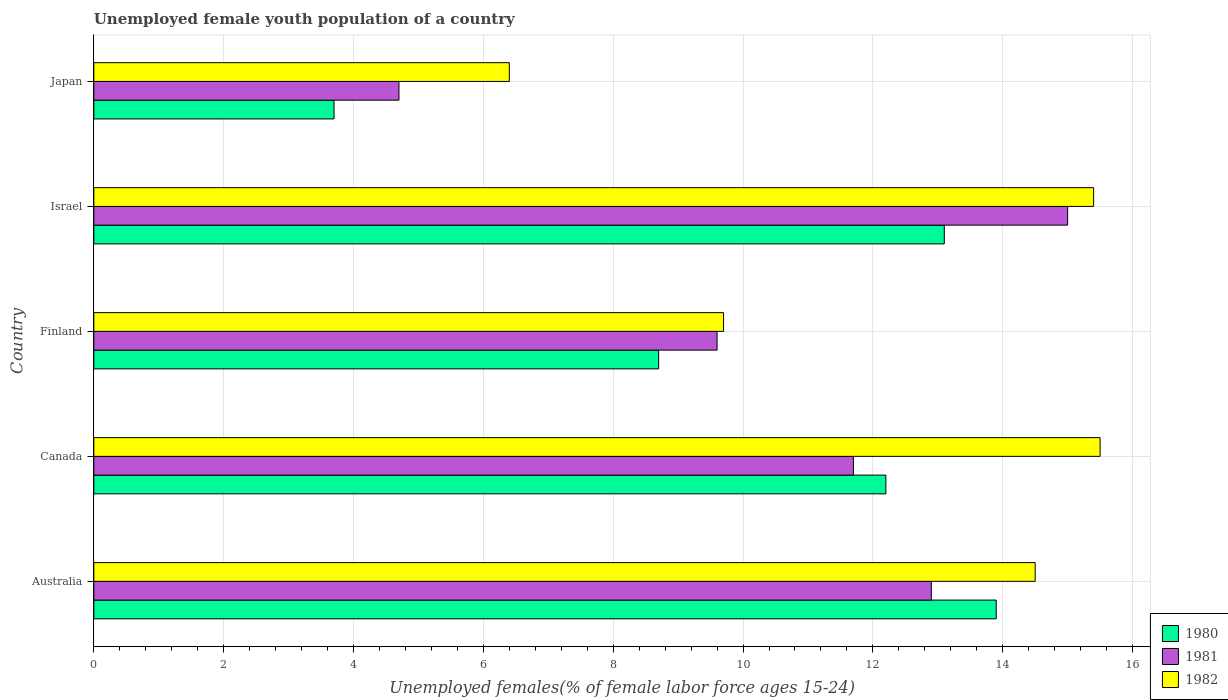How many different coloured bars are there?
Offer a terse response. 3. Are the number of bars per tick equal to the number of legend labels?
Offer a terse response. Yes. How many bars are there on the 4th tick from the bottom?
Provide a succinct answer. 3. What is the percentage of unemployed female youth population in 1982 in Australia?
Ensure brevity in your answer.  14.5. Across all countries, what is the minimum percentage of unemployed female youth population in 1981?
Offer a very short reply. 4.7. What is the total percentage of unemployed female youth population in 1982 in the graph?
Ensure brevity in your answer.  61.5. What is the difference between the percentage of unemployed female youth population in 1981 in Finland and that in Israel?
Your answer should be very brief. -5.4. What is the difference between the percentage of unemployed female youth population in 1980 in Japan and the percentage of unemployed female youth population in 1982 in Australia?
Provide a short and direct response. -10.8. What is the average percentage of unemployed female youth population in 1981 per country?
Your answer should be compact. 10.78. What is the difference between the percentage of unemployed female youth population in 1982 and percentage of unemployed female youth population in 1980 in Australia?
Make the answer very short. 0.6. In how many countries, is the percentage of unemployed female youth population in 1981 greater than 12.4 %?
Ensure brevity in your answer.  2. What is the ratio of the percentage of unemployed female youth population in 1982 in Canada to that in Israel?
Your response must be concise. 1.01. What is the difference between the highest and the second highest percentage of unemployed female youth population in 1982?
Make the answer very short. 0.1. What is the difference between the highest and the lowest percentage of unemployed female youth population in 1982?
Offer a very short reply. 9.1. In how many countries, is the percentage of unemployed female youth population in 1980 greater than the average percentage of unemployed female youth population in 1980 taken over all countries?
Provide a succinct answer. 3. Is it the case that in every country, the sum of the percentage of unemployed female youth population in 1982 and percentage of unemployed female youth population in 1980 is greater than the percentage of unemployed female youth population in 1981?
Offer a terse response. Yes. How many bars are there?
Your answer should be compact. 15. Are all the bars in the graph horizontal?
Your answer should be compact. Yes. How many countries are there in the graph?
Keep it short and to the point. 5. Does the graph contain grids?
Make the answer very short. Yes. How are the legend labels stacked?
Make the answer very short. Vertical. What is the title of the graph?
Ensure brevity in your answer.  Unemployed female youth population of a country. What is the label or title of the X-axis?
Your response must be concise. Unemployed females(% of female labor force ages 15-24). What is the label or title of the Y-axis?
Provide a short and direct response. Country. What is the Unemployed females(% of female labor force ages 15-24) of 1980 in Australia?
Give a very brief answer. 13.9. What is the Unemployed females(% of female labor force ages 15-24) of 1981 in Australia?
Keep it short and to the point. 12.9. What is the Unemployed females(% of female labor force ages 15-24) of 1980 in Canada?
Provide a short and direct response. 12.2. What is the Unemployed females(% of female labor force ages 15-24) in 1981 in Canada?
Ensure brevity in your answer.  11.7. What is the Unemployed females(% of female labor force ages 15-24) in 1980 in Finland?
Your answer should be compact. 8.7. What is the Unemployed females(% of female labor force ages 15-24) of 1981 in Finland?
Provide a succinct answer. 9.6. What is the Unemployed females(% of female labor force ages 15-24) in 1982 in Finland?
Offer a very short reply. 9.7. What is the Unemployed females(% of female labor force ages 15-24) in 1980 in Israel?
Provide a succinct answer. 13.1. What is the Unemployed females(% of female labor force ages 15-24) in 1982 in Israel?
Provide a succinct answer. 15.4. What is the Unemployed females(% of female labor force ages 15-24) of 1980 in Japan?
Ensure brevity in your answer.  3.7. What is the Unemployed females(% of female labor force ages 15-24) of 1981 in Japan?
Provide a short and direct response. 4.7. What is the Unemployed females(% of female labor force ages 15-24) of 1982 in Japan?
Provide a succinct answer. 6.4. Across all countries, what is the maximum Unemployed females(% of female labor force ages 15-24) in 1980?
Provide a succinct answer. 13.9. Across all countries, what is the maximum Unemployed females(% of female labor force ages 15-24) of 1982?
Give a very brief answer. 15.5. Across all countries, what is the minimum Unemployed females(% of female labor force ages 15-24) of 1980?
Your answer should be very brief. 3.7. Across all countries, what is the minimum Unemployed females(% of female labor force ages 15-24) of 1981?
Ensure brevity in your answer.  4.7. Across all countries, what is the minimum Unemployed females(% of female labor force ages 15-24) in 1982?
Your answer should be compact. 6.4. What is the total Unemployed females(% of female labor force ages 15-24) in 1980 in the graph?
Provide a succinct answer. 51.6. What is the total Unemployed females(% of female labor force ages 15-24) in 1981 in the graph?
Your answer should be very brief. 53.9. What is the total Unemployed females(% of female labor force ages 15-24) in 1982 in the graph?
Give a very brief answer. 61.5. What is the difference between the Unemployed females(% of female labor force ages 15-24) in 1980 in Australia and that in Canada?
Your answer should be very brief. 1.7. What is the difference between the Unemployed females(% of female labor force ages 15-24) of 1981 in Australia and that in Canada?
Provide a succinct answer. 1.2. What is the difference between the Unemployed females(% of female labor force ages 15-24) in 1982 in Australia and that in Canada?
Give a very brief answer. -1. What is the difference between the Unemployed females(% of female labor force ages 15-24) of 1982 in Australia and that in Finland?
Offer a very short reply. 4.8. What is the difference between the Unemployed females(% of female labor force ages 15-24) of 1980 in Australia and that in Israel?
Ensure brevity in your answer.  0.8. What is the difference between the Unemployed females(% of female labor force ages 15-24) in 1981 in Australia and that in Japan?
Offer a terse response. 8.2. What is the difference between the Unemployed females(% of female labor force ages 15-24) in 1980 in Canada and that in Finland?
Provide a short and direct response. 3.5. What is the difference between the Unemployed females(% of female labor force ages 15-24) of 1981 in Canada and that in Finland?
Keep it short and to the point. 2.1. What is the difference between the Unemployed females(% of female labor force ages 15-24) of 1982 in Canada and that in Finland?
Offer a terse response. 5.8. What is the difference between the Unemployed females(% of female labor force ages 15-24) in 1980 in Canada and that in Israel?
Offer a terse response. -0.9. What is the difference between the Unemployed females(% of female labor force ages 15-24) in 1981 in Canada and that in Japan?
Give a very brief answer. 7. What is the difference between the Unemployed females(% of female labor force ages 15-24) of 1982 in Canada and that in Japan?
Give a very brief answer. 9.1. What is the difference between the Unemployed females(% of female labor force ages 15-24) of 1982 in Finland and that in Israel?
Offer a very short reply. -5.7. What is the difference between the Unemployed females(% of female labor force ages 15-24) of 1980 in Finland and that in Japan?
Make the answer very short. 5. What is the difference between the Unemployed females(% of female labor force ages 15-24) in 1980 in Israel and that in Japan?
Your answer should be compact. 9.4. What is the difference between the Unemployed females(% of female labor force ages 15-24) in 1982 in Israel and that in Japan?
Give a very brief answer. 9. What is the difference between the Unemployed females(% of female labor force ages 15-24) of 1980 in Australia and the Unemployed females(% of female labor force ages 15-24) of 1981 in Canada?
Your answer should be compact. 2.2. What is the difference between the Unemployed females(% of female labor force ages 15-24) of 1980 in Australia and the Unemployed females(% of female labor force ages 15-24) of 1982 in Canada?
Ensure brevity in your answer.  -1.6. What is the difference between the Unemployed females(% of female labor force ages 15-24) in 1980 in Australia and the Unemployed females(% of female labor force ages 15-24) in 1981 in Finland?
Provide a short and direct response. 4.3. What is the difference between the Unemployed females(% of female labor force ages 15-24) in 1981 in Australia and the Unemployed females(% of female labor force ages 15-24) in 1982 in Finland?
Your response must be concise. 3.2. What is the difference between the Unemployed females(% of female labor force ages 15-24) in 1980 in Australia and the Unemployed females(% of female labor force ages 15-24) in 1981 in Israel?
Offer a terse response. -1.1. What is the difference between the Unemployed females(% of female labor force ages 15-24) of 1980 in Australia and the Unemployed females(% of female labor force ages 15-24) of 1982 in Israel?
Offer a very short reply. -1.5. What is the difference between the Unemployed females(% of female labor force ages 15-24) in 1980 in Canada and the Unemployed females(% of female labor force ages 15-24) in 1981 in Finland?
Your answer should be very brief. 2.6. What is the difference between the Unemployed females(% of female labor force ages 15-24) in 1980 in Canada and the Unemployed females(% of female labor force ages 15-24) in 1982 in Finland?
Provide a succinct answer. 2.5. What is the difference between the Unemployed females(% of female labor force ages 15-24) of 1981 in Canada and the Unemployed females(% of female labor force ages 15-24) of 1982 in Israel?
Offer a terse response. -3.7. What is the difference between the Unemployed females(% of female labor force ages 15-24) in 1980 in Finland and the Unemployed females(% of female labor force ages 15-24) in 1982 in Israel?
Keep it short and to the point. -6.7. What is the difference between the Unemployed females(% of female labor force ages 15-24) of 1980 in Finland and the Unemployed females(% of female labor force ages 15-24) of 1981 in Japan?
Give a very brief answer. 4. What is the difference between the Unemployed females(% of female labor force ages 15-24) of 1980 in Finland and the Unemployed females(% of female labor force ages 15-24) of 1982 in Japan?
Offer a very short reply. 2.3. What is the difference between the Unemployed females(% of female labor force ages 15-24) in 1981 in Israel and the Unemployed females(% of female labor force ages 15-24) in 1982 in Japan?
Make the answer very short. 8.6. What is the average Unemployed females(% of female labor force ages 15-24) in 1980 per country?
Provide a succinct answer. 10.32. What is the average Unemployed females(% of female labor force ages 15-24) in 1981 per country?
Give a very brief answer. 10.78. What is the difference between the Unemployed females(% of female labor force ages 15-24) of 1980 and Unemployed females(% of female labor force ages 15-24) of 1981 in Australia?
Make the answer very short. 1. What is the difference between the Unemployed females(% of female labor force ages 15-24) of 1980 and Unemployed females(% of female labor force ages 15-24) of 1982 in Australia?
Offer a very short reply. -0.6. What is the difference between the Unemployed females(% of female labor force ages 15-24) of 1981 and Unemployed females(% of female labor force ages 15-24) of 1982 in Australia?
Make the answer very short. -1.6. What is the difference between the Unemployed females(% of female labor force ages 15-24) of 1980 and Unemployed females(% of female labor force ages 15-24) of 1981 in Canada?
Ensure brevity in your answer.  0.5. What is the difference between the Unemployed females(% of female labor force ages 15-24) of 1980 and Unemployed females(% of female labor force ages 15-24) of 1981 in Finland?
Give a very brief answer. -0.9. What is the difference between the Unemployed females(% of female labor force ages 15-24) of 1980 and Unemployed females(% of female labor force ages 15-24) of 1982 in Finland?
Offer a very short reply. -1. What is the difference between the Unemployed females(% of female labor force ages 15-24) in 1980 and Unemployed females(% of female labor force ages 15-24) in 1981 in Israel?
Offer a terse response. -1.9. What is the difference between the Unemployed females(% of female labor force ages 15-24) of 1980 and Unemployed females(% of female labor force ages 15-24) of 1982 in Israel?
Your response must be concise. -2.3. What is the difference between the Unemployed females(% of female labor force ages 15-24) of 1981 and Unemployed females(% of female labor force ages 15-24) of 1982 in Japan?
Give a very brief answer. -1.7. What is the ratio of the Unemployed females(% of female labor force ages 15-24) of 1980 in Australia to that in Canada?
Your answer should be compact. 1.14. What is the ratio of the Unemployed females(% of female labor force ages 15-24) in 1981 in Australia to that in Canada?
Your response must be concise. 1.1. What is the ratio of the Unemployed females(% of female labor force ages 15-24) in 1982 in Australia to that in Canada?
Your answer should be very brief. 0.94. What is the ratio of the Unemployed females(% of female labor force ages 15-24) in 1980 in Australia to that in Finland?
Ensure brevity in your answer.  1.6. What is the ratio of the Unemployed females(% of female labor force ages 15-24) of 1981 in Australia to that in Finland?
Make the answer very short. 1.34. What is the ratio of the Unemployed females(% of female labor force ages 15-24) of 1982 in Australia to that in Finland?
Make the answer very short. 1.49. What is the ratio of the Unemployed females(% of female labor force ages 15-24) of 1980 in Australia to that in Israel?
Make the answer very short. 1.06. What is the ratio of the Unemployed females(% of female labor force ages 15-24) in 1981 in Australia to that in Israel?
Your response must be concise. 0.86. What is the ratio of the Unemployed females(% of female labor force ages 15-24) of 1982 in Australia to that in Israel?
Offer a very short reply. 0.94. What is the ratio of the Unemployed females(% of female labor force ages 15-24) of 1980 in Australia to that in Japan?
Ensure brevity in your answer.  3.76. What is the ratio of the Unemployed females(% of female labor force ages 15-24) in 1981 in Australia to that in Japan?
Your response must be concise. 2.74. What is the ratio of the Unemployed females(% of female labor force ages 15-24) of 1982 in Australia to that in Japan?
Offer a very short reply. 2.27. What is the ratio of the Unemployed females(% of female labor force ages 15-24) of 1980 in Canada to that in Finland?
Ensure brevity in your answer.  1.4. What is the ratio of the Unemployed females(% of female labor force ages 15-24) in 1981 in Canada to that in Finland?
Ensure brevity in your answer.  1.22. What is the ratio of the Unemployed females(% of female labor force ages 15-24) in 1982 in Canada to that in Finland?
Make the answer very short. 1.6. What is the ratio of the Unemployed females(% of female labor force ages 15-24) in 1980 in Canada to that in Israel?
Give a very brief answer. 0.93. What is the ratio of the Unemployed females(% of female labor force ages 15-24) of 1981 in Canada to that in Israel?
Make the answer very short. 0.78. What is the ratio of the Unemployed females(% of female labor force ages 15-24) of 1980 in Canada to that in Japan?
Make the answer very short. 3.3. What is the ratio of the Unemployed females(% of female labor force ages 15-24) in 1981 in Canada to that in Japan?
Offer a terse response. 2.49. What is the ratio of the Unemployed females(% of female labor force ages 15-24) in 1982 in Canada to that in Japan?
Your response must be concise. 2.42. What is the ratio of the Unemployed females(% of female labor force ages 15-24) in 1980 in Finland to that in Israel?
Offer a terse response. 0.66. What is the ratio of the Unemployed females(% of female labor force ages 15-24) of 1981 in Finland to that in Israel?
Keep it short and to the point. 0.64. What is the ratio of the Unemployed females(% of female labor force ages 15-24) of 1982 in Finland to that in Israel?
Keep it short and to the point. 0.63. What is the ratio of the Unemployed females(% of female labor force ages 15-24) in 1980 in Finland to that in Japan?
Keep it short and to the point. 2.35. What is the ratio of the Unemployed females(% of female labor force ages 15-24) in 1981 in Finland to that in Japan?
Your answer should be very brief. 2.04. What is the ratio of the Unemployed females(% of female labor force ages 15-24) in 1982 in Finland to that in Japan?
Make the answer very short. 1.52. What is the ratio of the Unemployed females(% of female labor force ages 15-24) in 1980 in Israel to that in Japan?
Give a very brief answer. 3.54. What is the ratio of the Unemployed females(% of female labor force ages 15-24) in 1981 in Israel to that in Japan?
Your response must be concise. 3.19. What is the ratio of the Unemployed females(% of female labor force ages 15-24) in 1982 in Israel to that in Japan?
Provide a succinct answer. 2.41. What is the difference between the highest and the second highest Unemployed females(% of female labor force ages 15-24) of 1980?
Your answer should be compact. 0.8. 